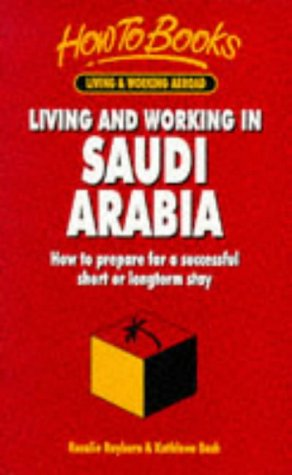Is this a journey related book? Indeed, it's a journey-related book, dedicated to helping readers navigate the unique challenges and opportunities of living and working in Saudi Arabia. 